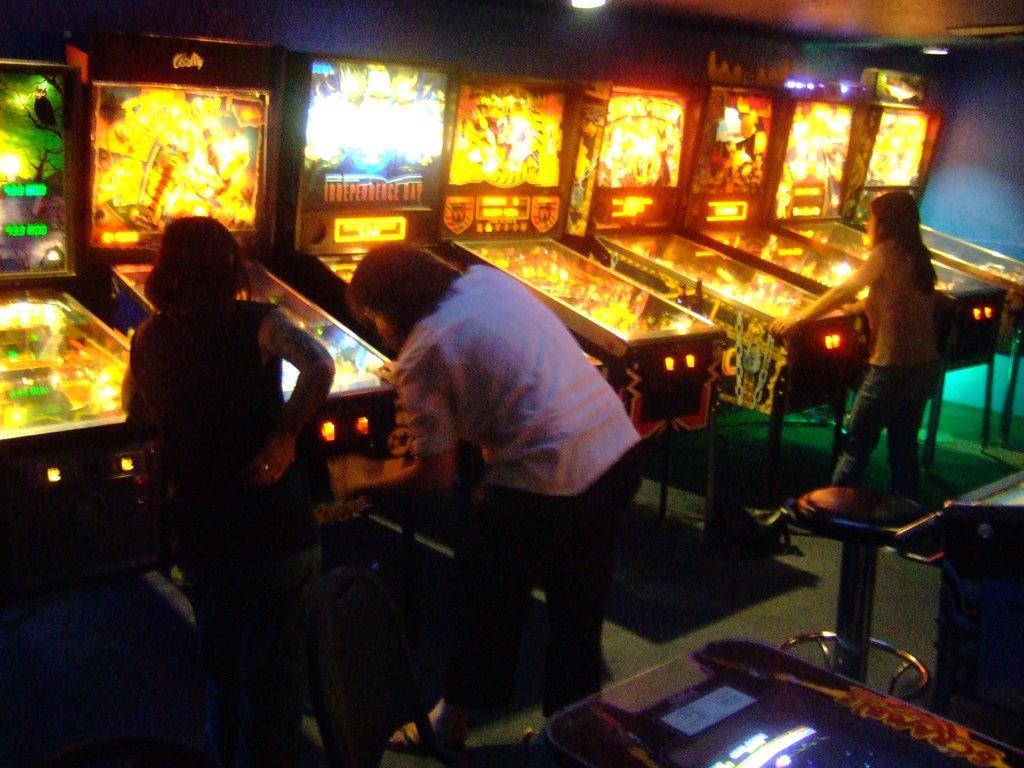Can you describe this image briefly? In this image in the center there are persons standing and playing a game, there is an empty stool and there is an empty chair and there are objects which are black in colour. In the background there are games and there are lights at the top. 